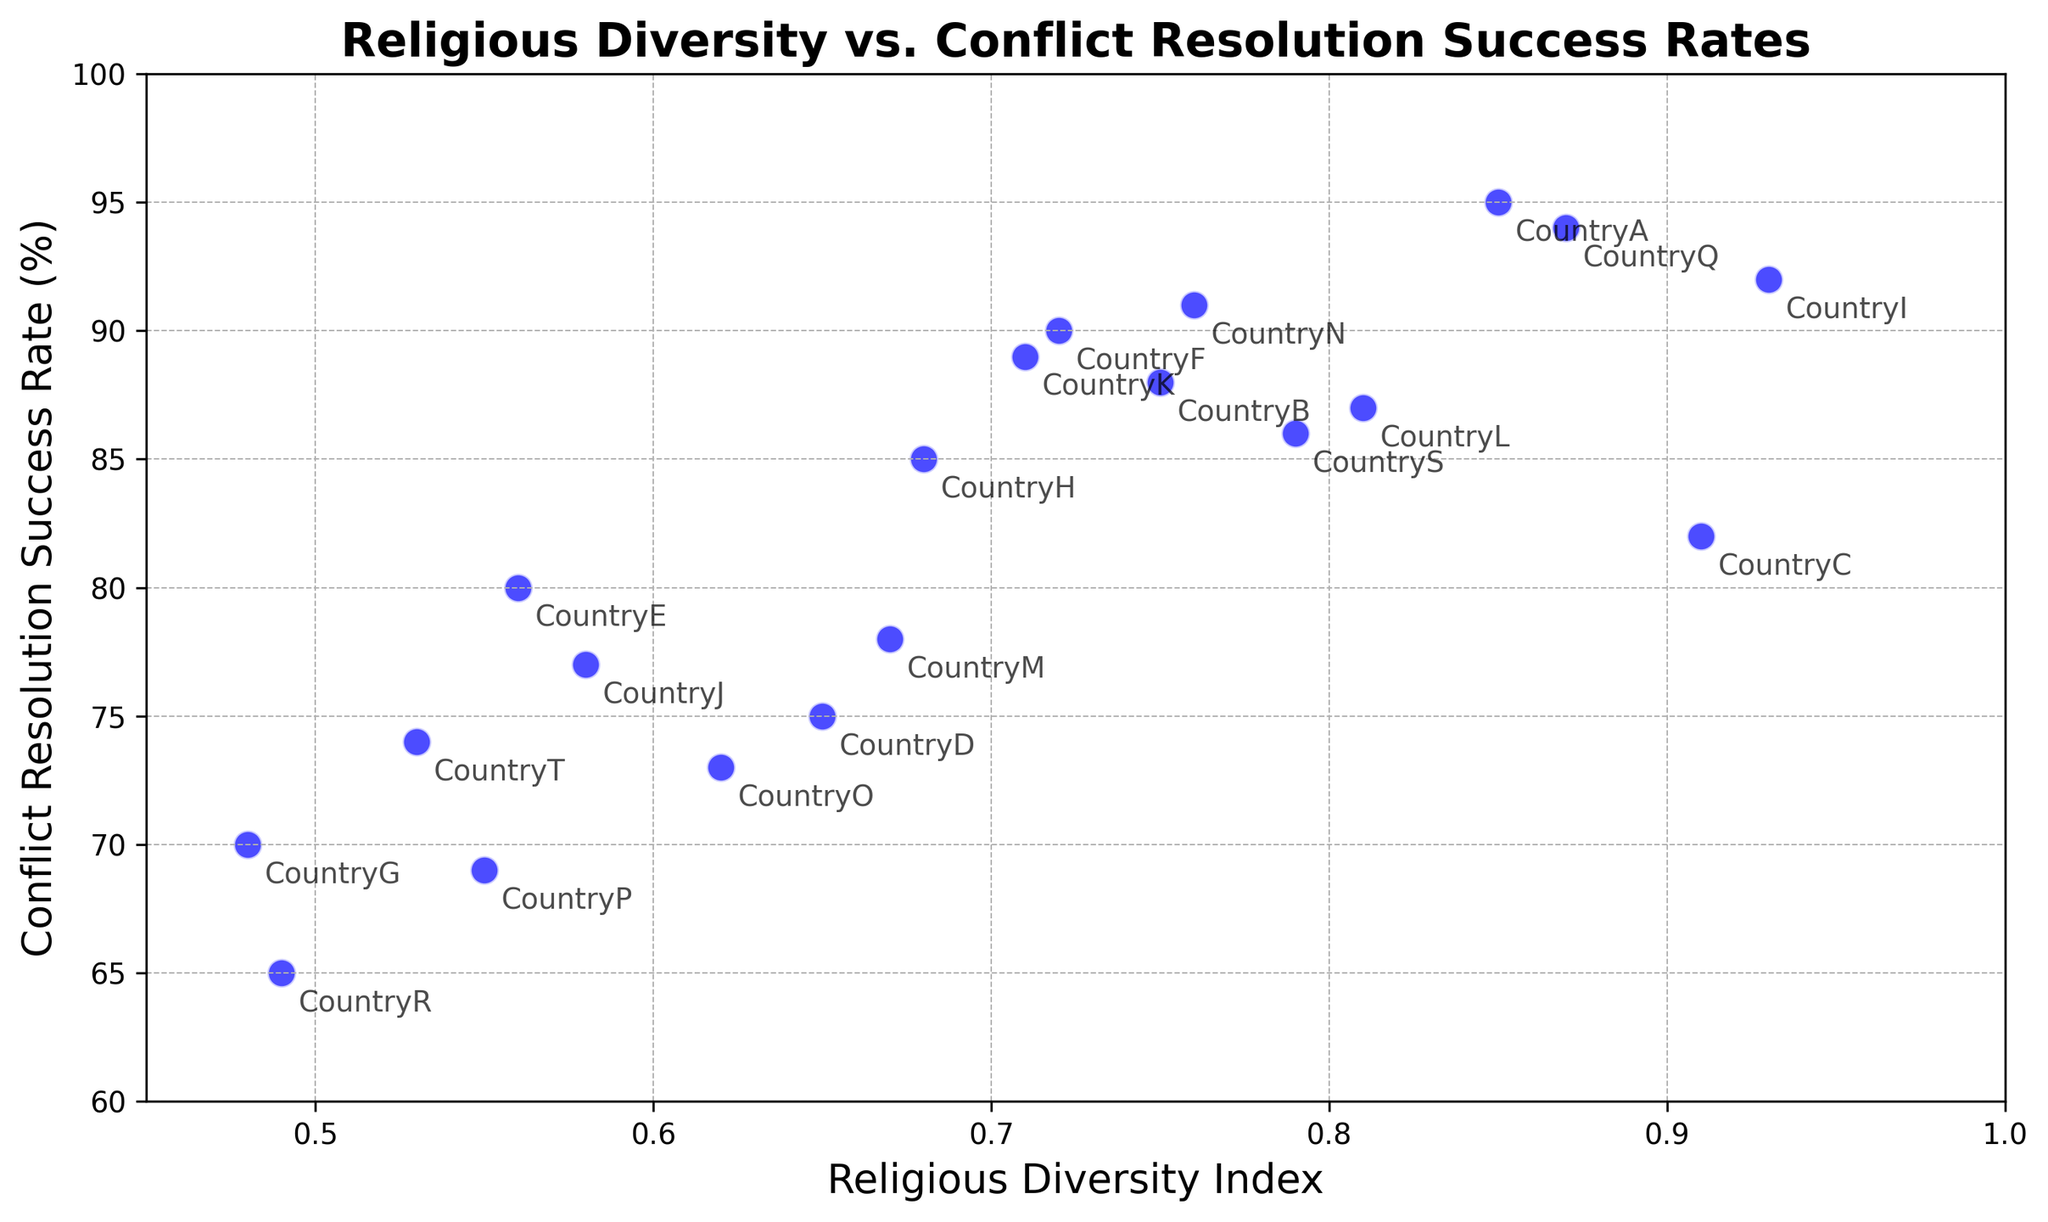Which country has the highest Religious Diversity Index? By visual inspection, the data point farthest to the right on the x-axis (Religious Diversity Index) represents the highest value. The country associated with this point is CountryI.
Answer: CountryI Which country has the lowest Conflict Resolution Success Rate? The lowest value on the y-axis (Conflict Resolution Success Rate) indicates the data point for the corresponding country. The point that is lowest on the y-axis corresponds to CountryR.
Answer: CountryR What is the average Conflict Resolution Success Rate of countries with Religious Diversity Index greater than 0.8? First, identify the countries with a Religious Diversity Index greater than 0.8: CountryA, CountryC, CountryI, CountryL, CountryQ. Their Success Rates are 95, 82, 92, 87, and 94. Summing these values gives 450. Dividing by 5 (the number of countries), the average is 450/5 = 90.
Answer: 90 How many countries have a Conflict Resolution Success Rate above 85%? Identify points on the figure above 85 on the y-axis: CountryA, CountryB, CountryF, CountryH, CountryI, CountryK, CountryN, CountryQ, CountryS. Count these countries, there are 9.
Answer: 9 Is there a general trend between Religious Diversity and Conflict Resolution Success Rate? Observing the scatter plot, there appears to be a somewhat positive correlation where higher Religious Diversity Index tends to align with higher Conflict Resolution Success Rate. This is evident as the points ascend diagonally from the bottom-left to the top-right.
Answer: Positive correlation Which countries have almost identical Conflict Resolution Success Rates but different Religious Diversity Indices? Look for points at the same height (y-axis) but different positions on the x-axis. CountryB and CountryL both have a Success Rate of 88% and 87% respectively, but different Diversity Indices (0.75 and 0.81). Also, CountryF and CountryN both have a Success Rate of 90% and 91% respectively, with 0.72 and 0.76 indices.
Answer: CountryB and CountryL; CountryF and CountryN Which country has a Religious Diversity Index closest to 0.65 but with a high Conflict Resolution Success Rate? Locate the point closest to 0.65 on the x-axis, and then check the y-axis for the highest Success Rate for these points. CountryD is close to 0.65 with a Success Rate of 75, but CountryH, with a 0.68 index and 85% rate, is both close and higher.
Answer: CountryH What is the combined Religious Diversity Index of the three countries with the lowest Conflict Resolution Success Rates? Identify the three countries with the lowest Success Rates (CountryR, CountryG, CountryP). Their Diversity Indices are 0.49, 0.48, and 0.55. Adding these together gives 0.49 + 0.48 + 0.55 = 1.52.
Answer: 1.52 